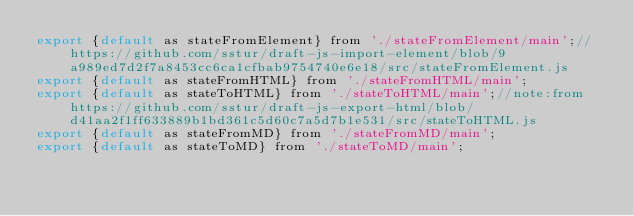<code> <loc_0><loc_0><loc_500><loc_500><_JavaScript_>export {default as stateFromElement} from './stateFromElement/main';//https://github.com/sstur/draft-js-import-element/blob/9a989ed7d2f7a8453cc6ca1cfbab9754740e6e18/src/stateFromElement.js
export {default as stateFromHTML} from './stateFromHTML/main';
export {default as stateToHTML} from './stateToHTML/main';//note:from https://github.com/sstur/draft-js-export-html/blob/d41aa2f1ff633889b1bd361c5d60c7a5d7b1e531/src/stateToHTML.js
export {default as stateFromMD} from './stateFromMD/main';
export {default as stateToMD} from './stateToMD/main';
</code> 